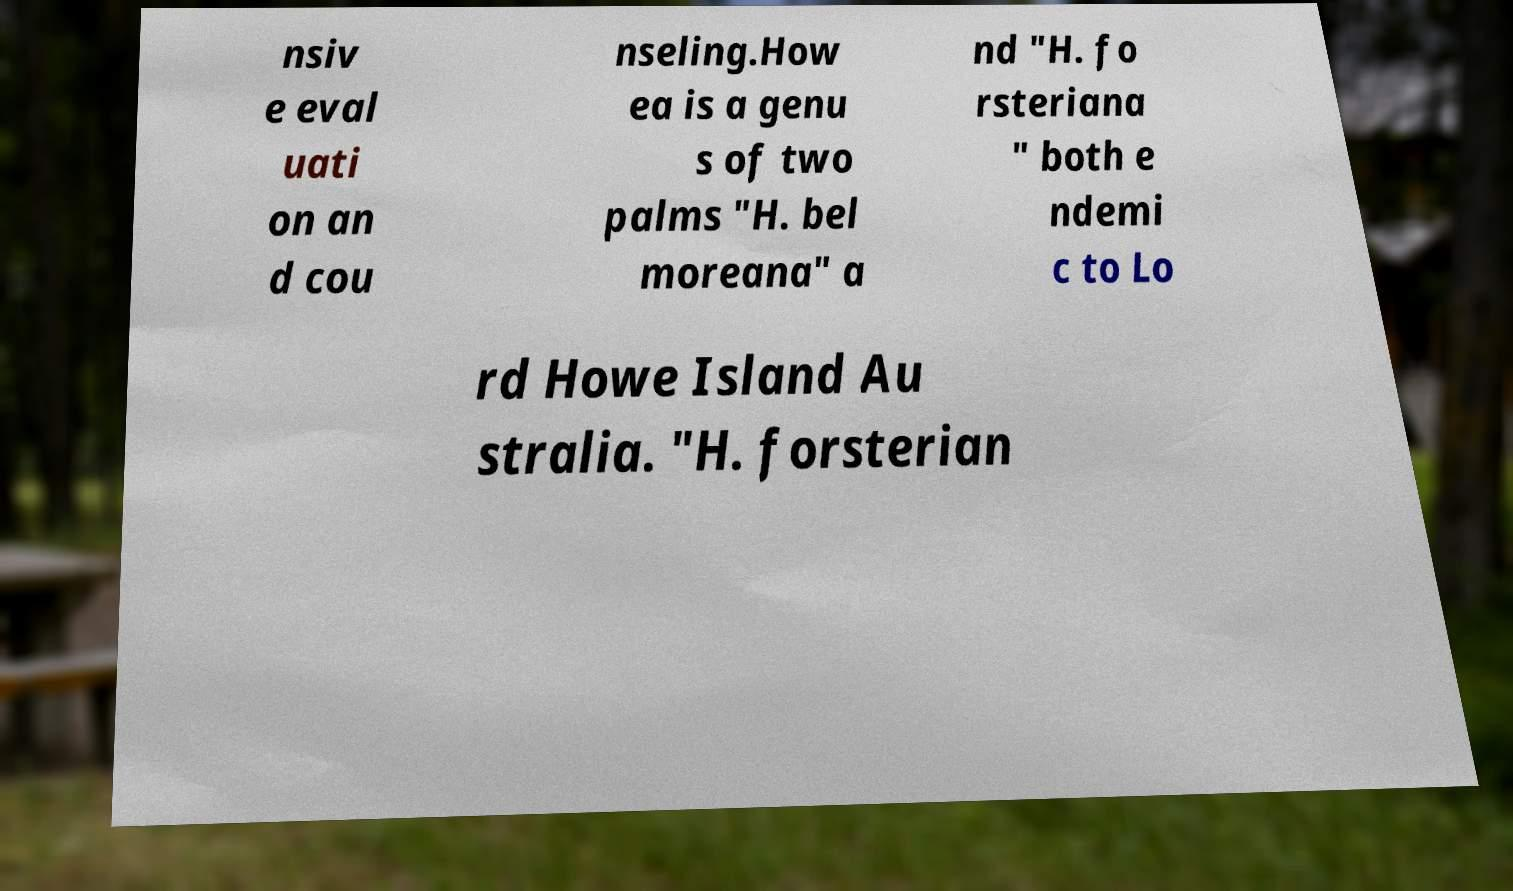For documentation purposes, I need the text within this image transcribed. Could you provide that? nsiv e eval uati on an d cou nseling.How ea is a genu s of two palms "H. bel moreana" a nd "H. fo rsteriana " both e ndemi c to Lo rd Howe Island Au stralia. "H. forsterian 